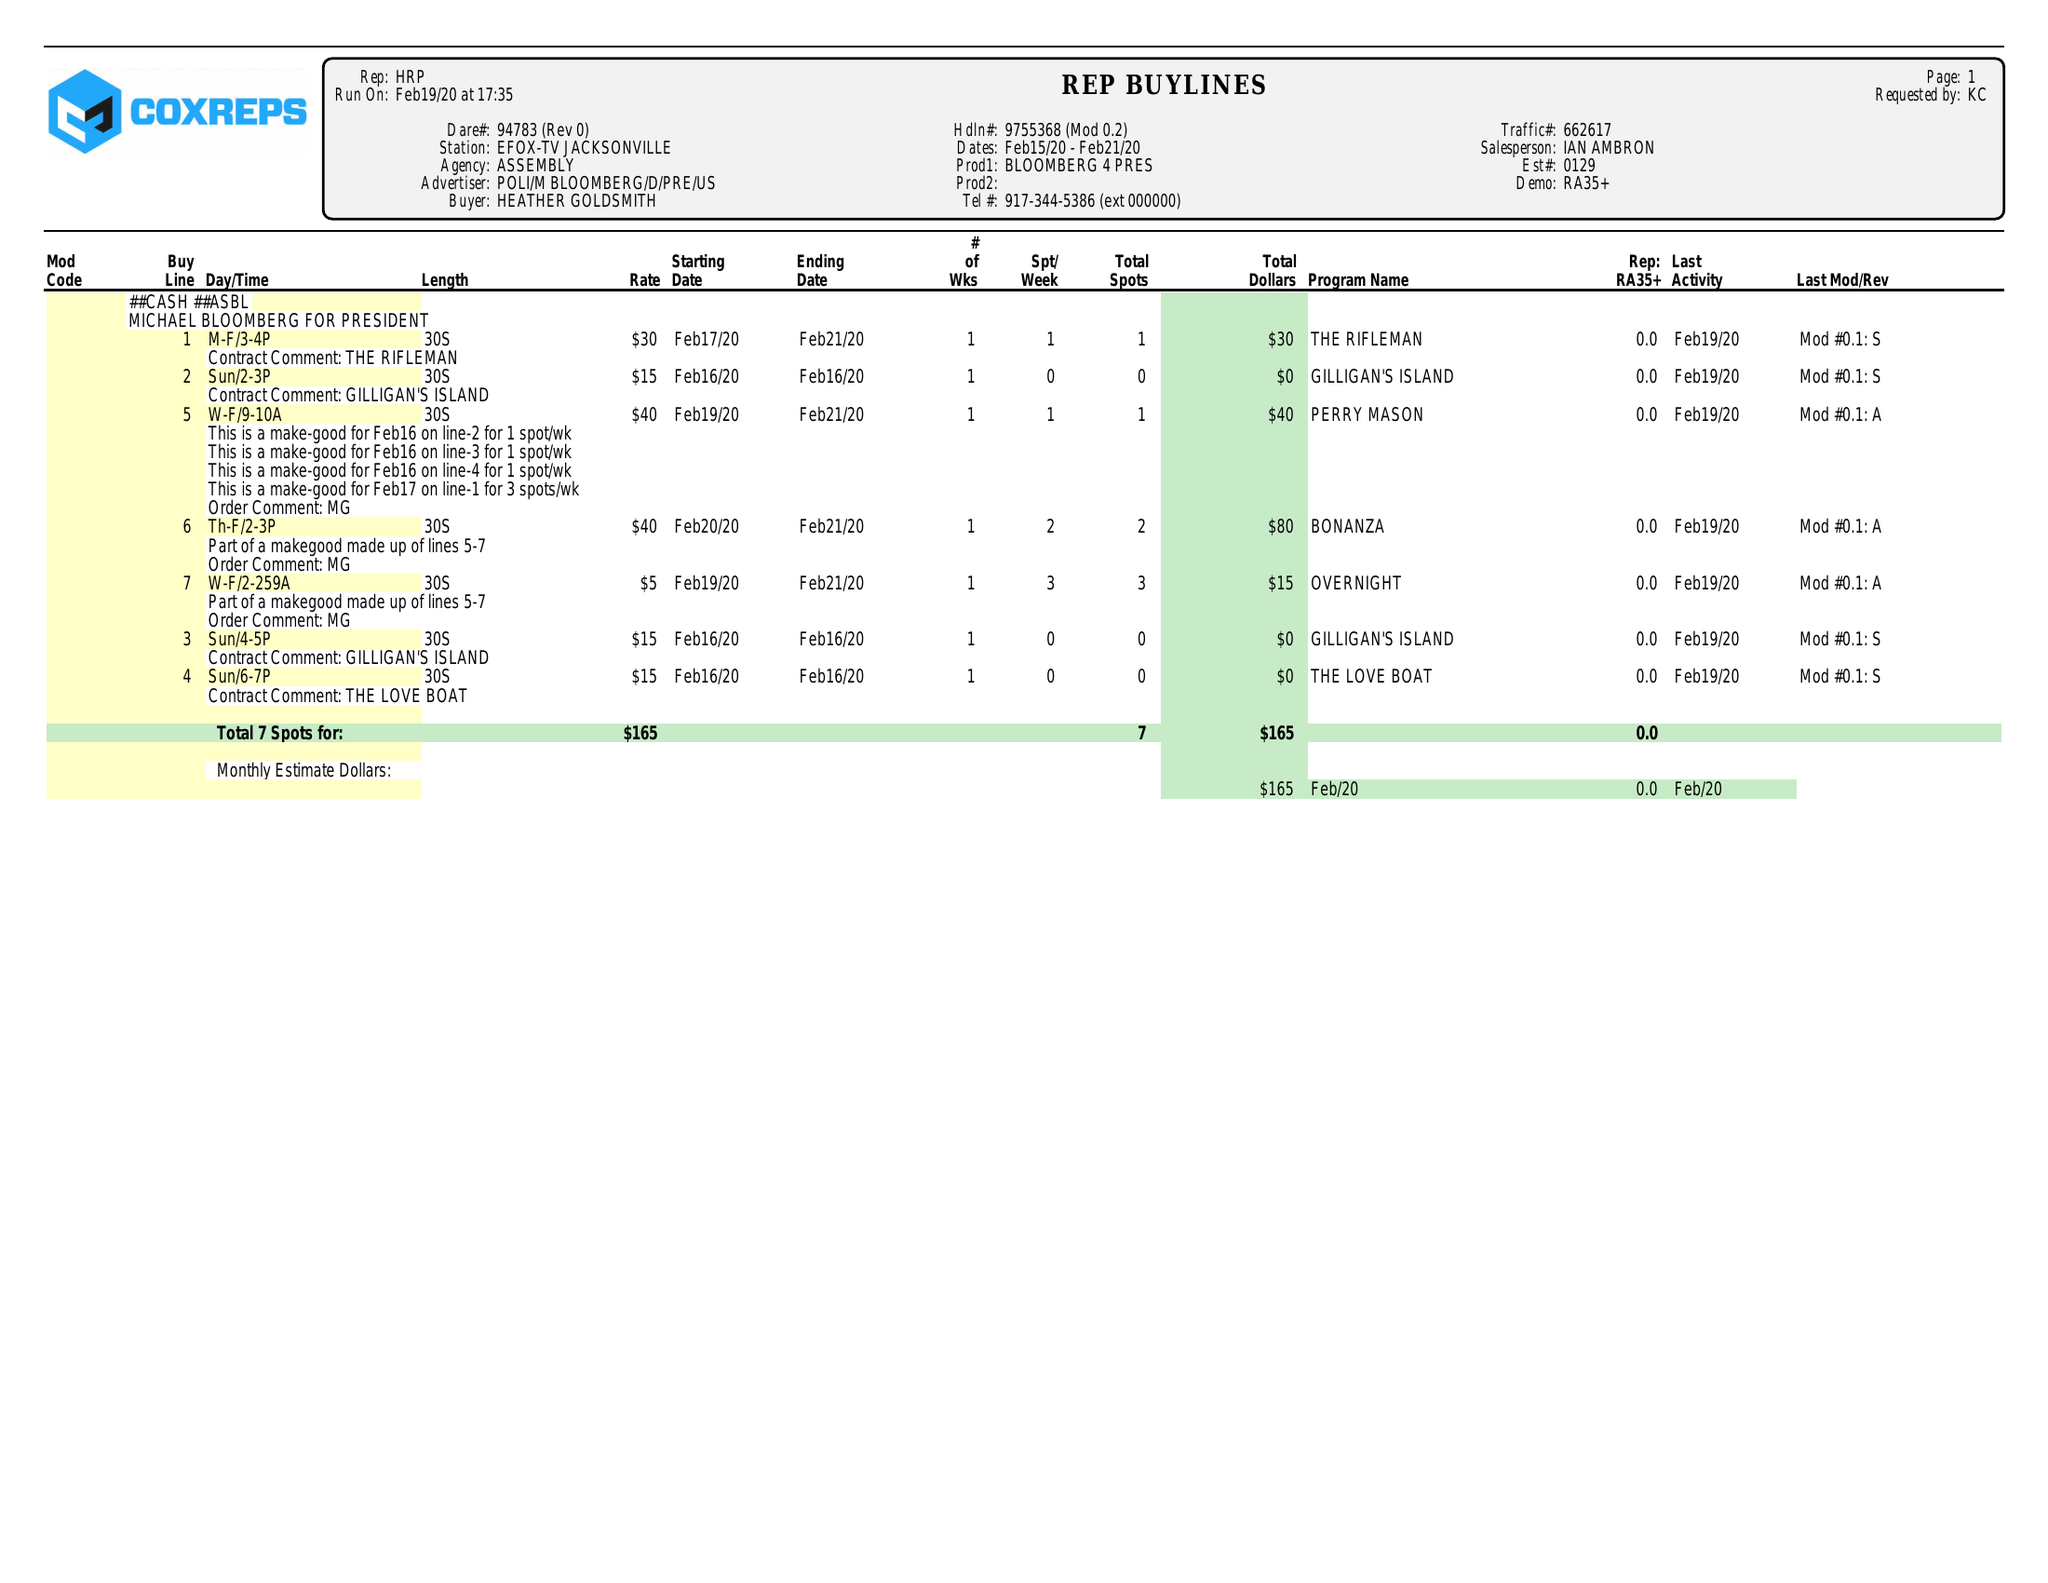What is the value for the advertiser?
Answer the question using a single word or phrase. POLI/MBLOOMBERG/D/PRE/US 